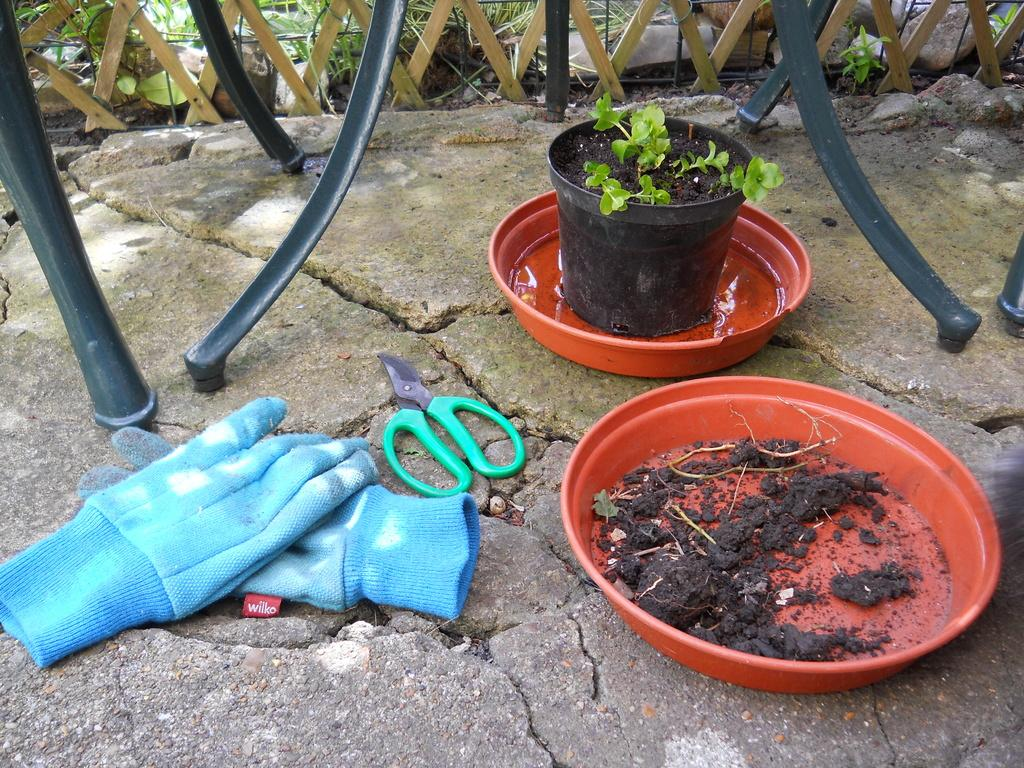What color are the gloves in the image? The gloves in the image are blue in color. What can be seen in the background of the image? There are plants in the background of the image. What is the color of the plants in the image? The plants in the image are green in color. What type of structure is visible in the image? There is fencing visible in the image. What color are the rods in the image? The rods in the image are black in color. What flavor of sugar can be seen in the image? There is no sugar present in the image, so it is not possible to determine the flavor. 